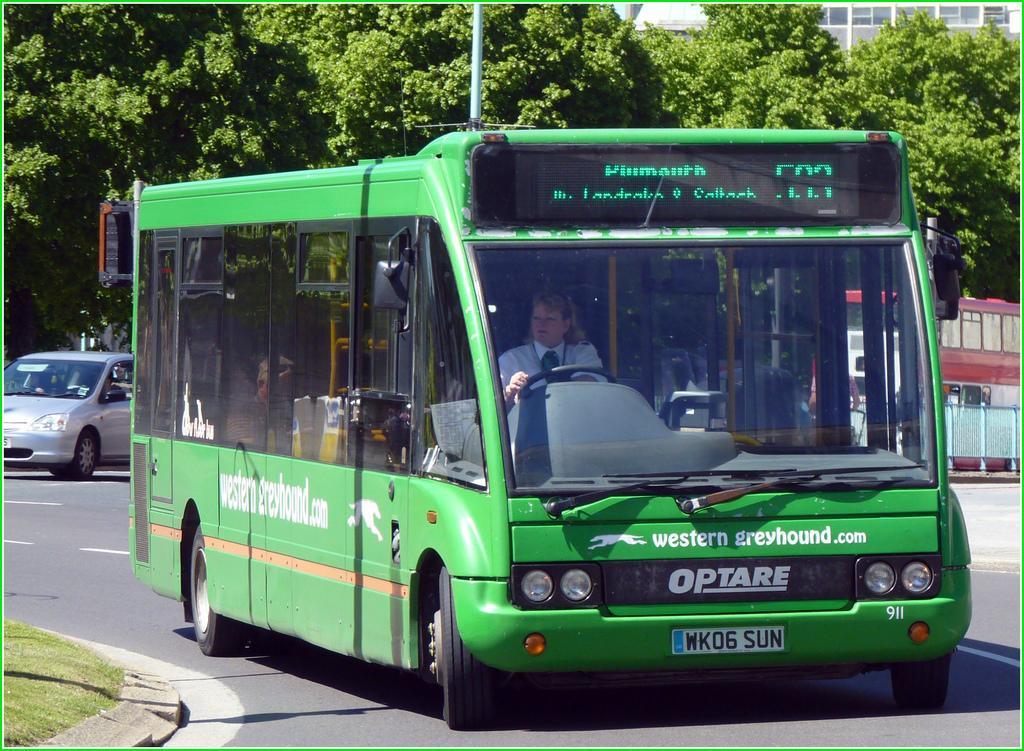Can you describe this image briefly? In this image we can see a person driving the bus. We can also see the vehicles passing on the road. We can see the barrier, grass, pole, building and also the trees and the image has borders. 